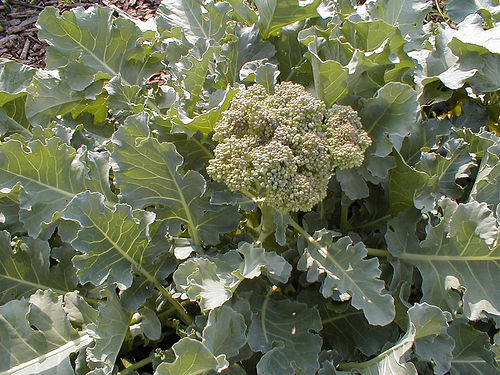Is this the usual environment for growing broccoli? Yes, broccoli thrives in a cool climate and is often grown in open fields. It needs well-drained, fertile soil and typically plenty of sunlight with moderate watering. From the image, it appears this broccoli is growing in an ideal environment tailored for such conditions. What are the benefits of growing your own broccoli? Growing your own broccoli offers several benefits including having a fresh supply of this nutritious vegetable that's rich in vitamins K and C, as well as fiber, folate, and antioxidants. Home-grown broccoli often tastes fresher and you can ensure it's grown without unwanted pesticides or chemicals. 